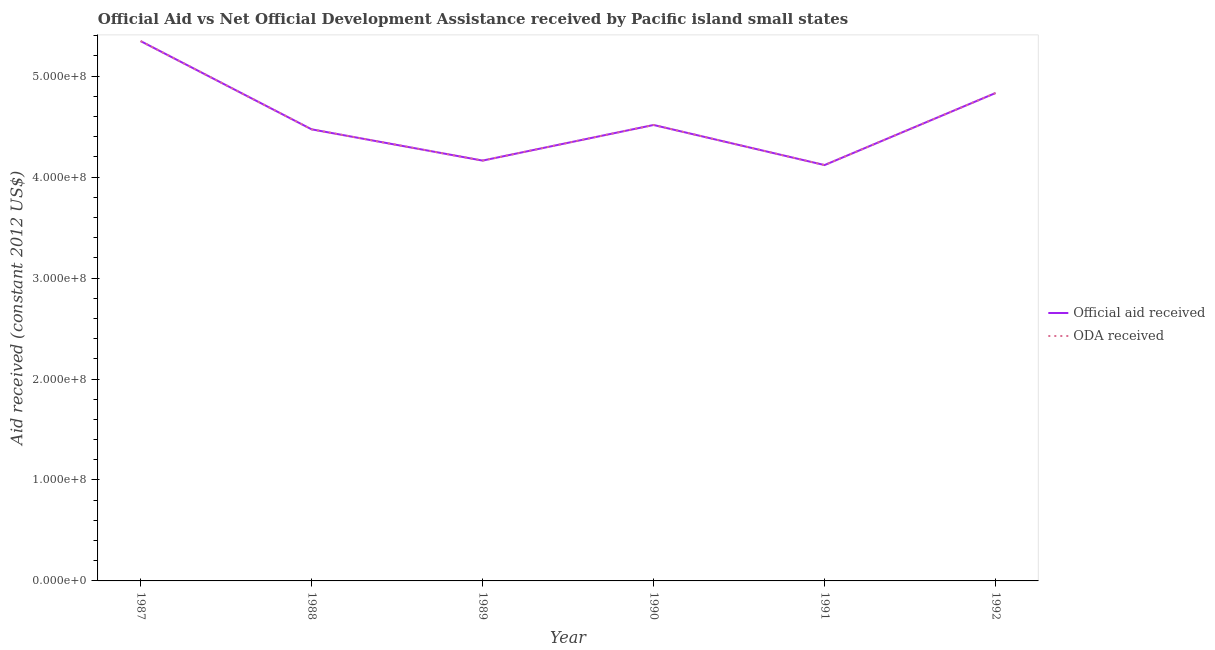Does the line corresponding to oda received intersect with the line corresponding to official aid received?
Provide a succinct answer. Yes. What is the official aid received in 1991?
Offer a very short reply. 4.12e+08. Across all years, what is the maximum official aid received?
Provide a succinct answer. 5.35e+08. Across all years, what is the minimum official aid received?
Give a very brief answer. 4.12e+08. In which year was the oda received maximum?
Ensure brevity in your answer.  1987. In which year was the official aid received minimum?
Offer a terse response. 1991. What is the total official aid received in the graph?
Your response must be concise. 2.75e+09. What is the difference between the oda received in 1988 and that in 1992?
Offer a terse response. -3.60e+07. What is the difference between the oda received in 1992 and the official aid received in 1988?
Ensure brevity in your answer.  3.60e+07. What is the average official aid received per year?
Offer a very short reply. 4.58e+08. In the year 1990, what is the difference between the oda received and official aid received?
Ensure brevity in your answer.  0. In how many years, is the official aid received greater than 60000000 US$?
Offer a terse response. 6. What is the ratio of the oda received in 1988 to that in 1989?
Offer a very short reply. 1.07. Is the official aid received in 1990 less than that in 1991?
Make the answer very short. No. Is the difference between the official aid received in 1990 and 1992 greater than the difference between the oda received in 1990 and 1992?
Provide a succinct answer. No. What is the difference between the highest and the second highest oda received?
Ensure brevity in your answer.  5.14e+07. What is the difference between the highest and the lowest oda received?
Offer a terse response. 1.23e+08. In how many years, is the official aid received greater than the average official aid received taken over all years?
Offer a very short reply. 2. Does the oda received monotonically increase over the years?
Keep it short and to the point. No. Is the oda received strictly greater than the official aid received over the years?
Keep it short and to the point. No. Is the oda received strictly less than the official aid received over the years?
Offer a very short reply. No. How many years are there in the graph?
Provide a succinct answer. 6. What is the difference between two consecutive major ticks on the Y-axis?
Keep it short and to the point. 1.00e+08. Are the values on the major ticks of Y-axis written in scientific E-notation?
Provide a succinct answer. Yes. Does the graph contain grids?
Provide a short and direct response. No. What is the title of the graph?
Give a very brief answer. Official Aid vs Net Official Development Assistance received by Pacific island small states . What is the label or title of the Y-axis?
Your answer should be compact. Aid received (constant 2012 US$). What is the Aid received (constant 2012 US$) of Official aid received in 1987?
Ensure brevity in your answer.  5.35e+08. What is the Aid received (constant 2012 US$) of ODA received in 1987?
Ensure brevity in your answer.  5.35e+08. What is the Aid received (constant 2012 US$) in Official aid received in 1988?
Keep it short and to the point. 4.47e+08. What is the Aid received (constant 2012 US$) of ODA received in 1988?
Your answer should be compact. 4.47e+08. What is the Aid received (constant 2012 US$) in Official aid received in 1989?
Provide a succinct answer. 4.16e+08. What is the Aid received (constant 2012 US$) of ODA received in 1989?
Your response must be concise. 4.16e+08. What is the Aid received (constant 2012 US$) of Official aid received in 1990?
Give a very brief answer. 4.52e+08. What is the Aid received (constant 2012 US$) of ODA received in 1990?
Make the answer very short. 4.52e+08. What is the Aid received (constant 2012 US$) in Official aid received in 1991?
Your answer should be very brief. 4.12e+08. What is the Aid received (constant 2012 US$) of ODA received in 1991?
Offer a very short reply. 4.12e+08. What is the Aid received (constant 2012 US$) in Official aid received in 1992?
Provide a succinct answer. 4.83e+08. What is the Aid received (constant 2012 US$) in ODA received in 1992?
Ensure brevity in your answer.  4.83e+08. Across all years, what is the maximum Aid received (constant 2012 US$) of Official aid received?
Offer a very short reply. 5.35e+08. Across all years, what is the maximum Aid received (constant 2012 US$) of ODA received?
Keep it short and to the point. 5.35e+08. Across all years, what is the minimum Aid received (constant 2012 US$) of Official aid received?
Your response must be concise. 4.12e+08. Across all years, what is the minimum Aid received (constant 2012 US$) of ODA received?
Give a very brief answer. 4.12e+08. What is the total Aid received (constant 2012 US$) of Official aid received in the graph?
Give a very brief answer. 2.75e+09. What is the total Aid received (constant 2012 US$) of ODA received in the graph?
Offer a very short reply. 2.75e+09. What is the difference between the Aid received (constant 2012 US$) of Official aid received in 1987 and that in 1988?
Your answer should be very brief. 8.74e+07. What is the difference between the Aid received (constant 2012 US$) of ODA received in 1987 and that in 1988?
Keep it short and to the point. 8.74e+07. What is the difference between the Aid received (constant 2012 US$) of Official aid received in 1987 and that in 1989?
Your answer should be compact. 1.18e+08. What is the difference between the Aid received (constant 2012 US$) of ODA received in 1987 and that in 1989?
Keep it short and to the point. 1.18e+08. What is the difference between the Aid received (constant 2012 US$) of Official aid received in 1987 and that in 1990?
Your answer should be very brief. 8.31e+07. What is the difference between the Aid received (constant 2012 US$) in ODA received in 1987 and that in 1990?
Keep it short and to the point. 8.31e+07. What is the difference between the Aid received (constant 2012 US$) in Official aid received in 1987 and that in 1991?
Keep it short and to the point. 1.23e+08. What is the difference between the Aid received (constant 2012 US$) of ODA received in 1987 and that in 1991?
Offer a very short reply. 1.23e+08. What is the difference between the Aid received (constant 2012 US$) of Official aid received in 1987 and that in 1992?
Ensure brevity in your answer.  5.14e+07. What is the difference between the Aid received (constant 2012 US$) of ODA received in 1987 and that in 1992?
Give a very brief answer. 5.14e+07. What is the difference between the Aid received (constant 2012 US$) of Official aid received in 1988 and that in 1989?
Offer a very short reply. 3.10e+07. What is the difference between the Aid received (constant 2012 US$) of ODA received in 1988 and that in 1989?
Make the answer very short. 3.10e+07. What is the difference between the Aid received (constant 2012 US$) in Official aid received in 1988 and that in 1990?
Offer a terse response. -4.32e+06. What is the difference between the Aid received (constant 2012 US$) in ODA received in 1988 and that in 1990?
Keep it short and to the point. -4.32e+06. What is the difference between the Aid received (constant 2012 US$) of Official aid received in 1988 and that in 1991?
Make the answer very short. 3.54e+07. What is the difference between the Aid received (constant 2012 US$) in ODA received in 1988 and that in 1991?
Your answer should be very brief. 3.54e+07. What is the difference between the Aid received (constant 2012 US$) of Official aid received in 1988 and that in 1992?
Give a very brief answer. -3.60e+07. What is the difference between the Aid received (constant 2012 US$) in ODA received in 1988 and that in 1992?
Offer a very short reply. -3.60e+07. What is the difference between the Aid received (constant 2012 US$) of Official aid received in 1989 and that in 1990?
Keep it short and to the point. -3.53e+07. What is the difference between the Aid received (constant 2012 US$) of ODA received in 1989 and that in 1990?
Ensure brevity in your answer.  -3.53e+07. What is the difference between the Aid received (constant 2012 US$) of Official aid received in 1989 and that in 1991?
Provide a short and direct response. 4.43e+06. What is the difference between the Aid received (constant 2012 US$) of ODA received in 1989 and that in 1991?
Ensure brevity in your answer.  4.43e+06. What is the difference between the Aid received (constant 2012 US$) of Official aid received in 1989 and that in 1992?
Provide a short and direct response. -6.69e+07. What is the difference between the Aid received (constant 2012 US$) of ODA received in 1989 and that in 1992?
Your response must be concise. -6.69e+07. What is the difference between the Aid received (constant 2012 US$) in Official aid received in 1990 and that in 1991?
Your response must be concise. 3.97e+07. What is the difference between the Aid received (constant 2012 US$) of ODA received in 1990 and that in 1991?
Provide a short and direct response. 3.97e+07. What is the difference between the Aid received (constant 2012 US$) in Official aid received in 1990 and that in 1992?
Make the answer very short. -3.17e+07. What is the difference between the Aid received (constant 2012 US$) in ODA received in 1990 and that in 1992?
Your answer should be very brief. -3.17e+07. What is the difference between the Aid received (constant 2012 US$) of Official aid received in 1991 and that in 1992?
Your answer should be very brief. -7.14e+07. What is the difference between the Aid received (constant 2012 US$) of ODA received in 1991 and that in 1992?
Make the answer very short. -7.14e+07. What is the difference between the Aid received (constant 2012 US$) of Official aid received in 1987 and the Aid received (constant 2012 US$) of ODA received in 1988?
Offer a terse response. 8.74e+07. What is the difference between the Aid received (constant 2012 US$) of Official aid received in 1987 and the Aid received (constant 2012 US$) of ODA received in 1989?
Your answer should be compact. 1.18e+08. What is the difference between the Aid received (constant 2012 US$) of Official aid received in 1987 and the Aid received (constant 2012 US$) of ODA received in 1990?
Provide a succinct answer. 8.31e+07. What is the difference between the Aid received (constant 2012 US$) of Official aid received in 1987 and the Aid received (constant 2012 US$) of ODA received in 1991?
Provide a short and direct response. 1.23e+08. What is the difference between the Aid received (constant 2012 US$) of Official aid received in 1987 and the Aid received (constant 2012 US$) of ODA received in 1992?
Give a very brief answer. 5.14e+07. What is the difference between the Aid received (constant 2012 US$) of Official aid received in 1988 and the Aid received (constant 2012 US$) of ODA received in 1989?
Offer a very short reply. 3.10e+07. What is the difference between the Aid received (constant 2012 US$) in Official aid received in 1988 and the Aid received (constant 2012 US$) in ODA received in 1990?
Offer a terse response. -4.32e+06. What is the difference between the Aid received (constant 2012 US$) in Official aid received in 1988 and the Aid received (constant 2012 US$) in ODA received in 1991?
Offer a terse response. 3.54e+07. What is the difference between the Aid received (constant 2012 US$) in Official aid received in 1988 and the Aid received (constant 2012 US$) in ODA received in 1992?
Give a very brief answer. -3.60e+07. What is the difference between the Aid received (constant 2012 US$) in Official aid received in 1989 and the Aid received (constant 2012 US$) in ODA received in 1990?
Make the answer very short. -3.53e+07. What is the difference between the Aid received (constant 2012 US$) of Official aid received in 1989 and the Aid received (constant 2012 US$) of ODA received in 1991?
Keep it short and to the point. 4.43e+06. What is the difference between the Aid received (constant 2012 US$) in Official aid received in 1989 and the Aid received (constant 2012 US$) in ODA received in 1992?
Provide a short and direct response. -6.69e+07. What is the difference between the Aid received (constant 2012 US$) of Official aid received in 1990 and the Aid received (constant 2012 US$) of ODA received in 1991?
Give a very brief answer. 3.97e+07. What is the difference between the Aid received (constant 2012 US$) in Official aid received in 1990 and the Aid received (constant 2012 US$) in ODA received in 1992?
Offer a terse response. -3.17e+07. What is the difference between the Aid received (constant 2012 US$) in Official aid received in 1991 and the Aid received (constant 2012 US$) in ODA received in 1992?
Your response must be concise. -7.14e+07. What is the average Aid received (constant 2012 US$) of Official aid received per year?
Provide a short and direct response. 4.58e+08. What is the average Aid received (constant 2012 US$) in ODA received per year?
Give a very brief answer. 4.58e+08. In the year 1987, what is the difference between the Aid received (constant 2012 US$) of Official aid received and Aid received (constant 2012 US$) of ODA received?
Offer a terse response. 0. In the year 1988, what is the difference between the Aid received (constant 2012 US$) of Official aid received and Aid received (constant 2012 US$) of ODA received?
Your answer should be very brief. 0. In the year 1989, what is the difference between the Aid received (constant 2012 US$) of Official aid received and Aid received (constant 2012 US$) of ODA received?
Offer a terse response. 0. In the year 1990, what is the difference between the Aid received (constant 2012 US$) of Official aid received and Aid received (constant 2012 US$) of ODA received?
Your response must be concise. 0. In the year 1991, what is the difference between the Aid received (constant 2012 US$) in Official aid received and Aid received (constant 2012 US$) in ODA received?
Your answer should be very brief. 0. In the year 1992, what is the difference between the Aid received (constant 2012 US$) in Official aid received and Aid received (constant 2012 US$) in ODA received?
Ensure brevity in your answer.  0. What is the ratio of the Aid received (constant 2012 US$) of Official aid received in 1987 to that in 1988?
Offer a terse response. 1.2. What is the ratio of the Aid received (constant 2012 US$) in ODA received in 1987 to that in 1988?
Give a very brief answer. 1.2. What is the ratio of the Aid received (constant 2012 US$) in Official aid received in 1987 to that in 1989?
Give a very brief answer. 1.28. What is the ratio of the Aid received (constant 2012 US$) of ODA received in 1987 to that in 1989?
Ensure brevity in your answer.  1.28. What is the ratio of the Aid received (constant 2012 US$) of Official aid received in 1987 to that in 1990?
Provide a short and direct response. 1.18. What is the ratio of the Aid received (constant 2012 US$) in ODA received in 1987 to that in 1990?
Make the answer very short. 1.18. What is the ratio of the Aid received (constant 2012 US$) of Official aid received in 1987 to that in 1991?
Your response must be concise. 1.3. What is the ratio of the Aid received (constant 2012 US$) of ODA received in 1987 to that in 1991?
Offer a very short reply. 1.3. What is the ratio of the Aid received (constant 2012 US$) in Official aid received in 1987 to that in 1992?
Your response must be concise. 1.11. What is the ratio of the Aid received (constant 2012 US$) in ODA received in 1987 to that in 1992?
Give a very brief answer. 1.11. What is the ratio of the Aid received (constant 2012 US$) in Official aid received in 1988 to that in 1989?
Ensure brevity in your answer.  1.07. What is the ratio of the Aid received (constant 2012 US$) of ODA received in 1988 to that in 1989?
Provide a short and direct response. 1.07. What is the ratio of the Aid received (constant 2012 US$) in Official aid received in 1988 to that in 1990?
Your answer should be very brief. 0.99. What is the ratio of the Aid received (constant 2012 US$) of Official aid received in 1988 to that in 1991?
Your answer should be very brief. 1.09. What is the ratio of the Aid received (constant 2012 US$) of ODA received in 1988 to that in 1991?
Your response must be concise. 1.09. What is the ratio of the Aid received (constant 2012 US$) of Official aid received in 1988 to that in 1992?
Offer a terse response. 0.93. What is the ratio of the Aid received (constant 2012 US$) in ODA received in 1988 to that in 1992?
Keep it short and to the point. 0.93. What is the ratio of the Aid received (constant 2012 US$) of Official aid received in 1989 to that in 1990?
Ensure brevity in your answer.  0.92. What is the ratio of the Aid received (constant 2012 US$) in ODA received in 1989 to that in 1990?
Your answer should be compact. 0.92. What is the ratio of the Aid received (constant 2012 US$) of Official aid received in 1989 to that in 1991?
Provide a short and direct response. 1.01. What is the ratio of the Aid received (constant 2012 US$) in ODA received in 1989 to that in 1991?
Your answer should be compact. 1.01. What is the ratio of the Aid received (constant 2012 US$) in Official aid received in 1989 to that in 1992?
Provide a succinct answer. 0.86. What is the ratio of the Aid received (constant 2012 US$) in ODA received in 1989 to that in 1992?
Your response must be concise. 0.86. What is the ratio of the Aid received (constant 2012 US$) in Official aid received in 1990 to that in 1991?
Your answer should be compact. 1.1. What is the ratio of the Aid received (constant 2012 US$) in ODA received in 1990 to that in 1991?
Keep it short and to the point. 1.1. What is the ratio of the Aid received (constant 2012 US$) of Official aid received in 1990 to that in 1992?
Your response must be concise. 0.93. What is the ratio of the Aid received (constant 2012 US$) in ODA received in 1990 to that in 1992?
Give a very brief answer. 0.93. What is the ratio of the Aid received (constant 2012 US$) in Official aid received in 1991 to that in 1992?
Make the answer very short. 0.85. What is the ratio of the Aid received (constant 2012 US$) of ODA received in 1991 to that in 1992?
Offer a terse response. 0.85. What is the difference between the highest and the second highest Aid received (constant 2012 US$) of Official aid received?
Your answer should be compact. 5.14e+07. What is the difference between the highest and the second highest Aid received (constant 2012 US$) in ODA received?
Keep it short and to the point. 5.14e+07. What is the difference between the highest and the lowest Aid received (constant 2012 US$) in Official aid received?
Ensure brevity in your answer.  1.23e+08. What is the difference between the highest and the lowest Aid received (constant 2012 US$) in ODA received?
Ensure brevity in your answer.  1.23e+08. 